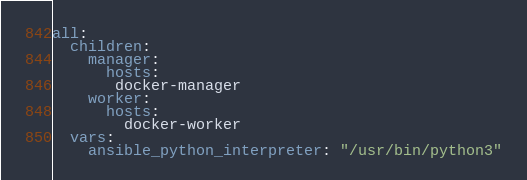<code> <loc_0><loc_0><loc_500><loc_500><_YAML_>all:
  children:
    manager:
      hosts:
       docker-manager
    worker:
      hosts:
        docker-worker
  vars:
    ansible_python_interpreter: "/usr/bin/python3"</code> 